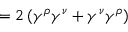<formula> <loc_0><loc_0><loc_500><loc_500>= 2 \left ( \gamma ^ { \rho } \gamma ^ { \nu } + \gamma ^ { \nu } \gamma ^ { \rho } \right )</formula> 